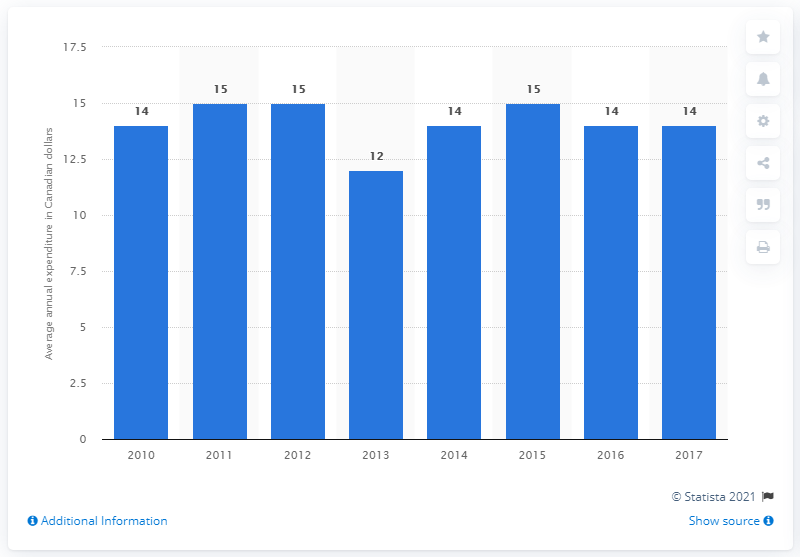What was the average annual household expenditure on microwave ovens in Canada in 2017? In 2017, the average annual household expenditure on microwave ovens in Canada was 14 Canadian dollars. As seen in the image, this represents a consistent value observed in most years except for a notable drop to 12 dollars in 2013. 